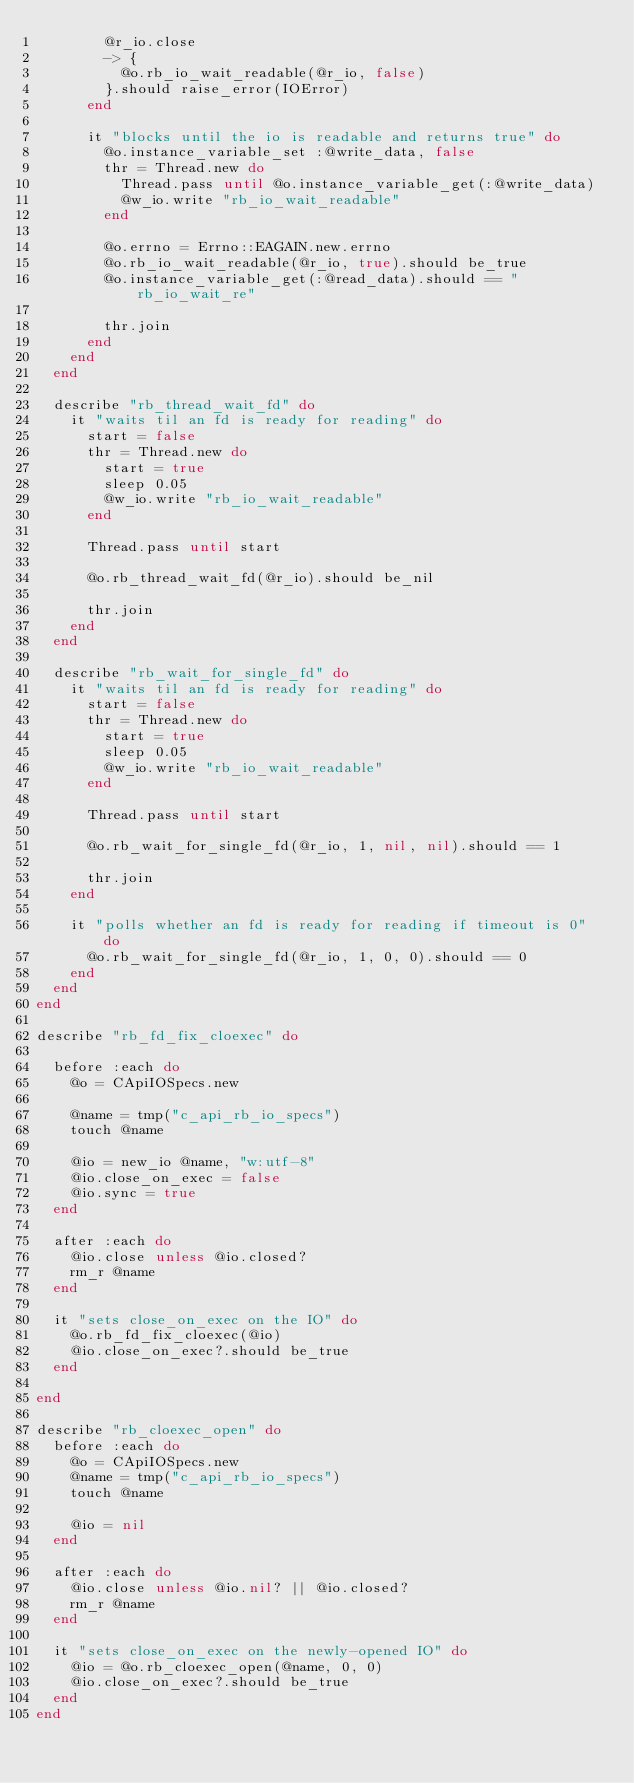Convert code to text. <code><loc_0><loc_0><loc_500><loc_500><_Ruby_>        @r_io.close
        -> {
          @o.rb_io_wait_readable(@r_io, false)
        }.should raise_error(IOError)
      end

      it "blocks until the io is readable and returns true" do
        @o.instance_variable_set :@write_data, false
        thr = Thread.new do
          Thread.pass until @o.instance_variable_get(:@write_data)
          @w_io.write "rb_io_wait_readable"
        end

        @o.errno = Errno::EAGAIN.new.errno
        @o.rb_io_wait_readable(@r_io, true).should be_true
        @o.instance_variable_get(:@read_data).should == "rb_io_wait_re"

        thr.join
      end
    end
  end

  describe "rb_thread_wait_fd" do
    it "waits til an fd is ready for reading" do
      start = false
      thr = Thread.new do
        start = true
        sleep 0.05
        @w_io.write "rb_io_wait_readable"
      end

      Thread.pass until start

      @o.rb_thread_wait_fd(@r_io).should be_nil

      thr.join
    end
  end

  describe "rb_wait_for_single_fd" do
    it "waits til an fd is ready for reading" do
      start = false
      thr = Thread.new do
        start = true
        sleep 0.05
        @w_io.write "rb_io_wait_readable"
      end

      Thread.pass until start

      @o.rb_wait_for_single_fd(@r_io, 1, nil, nil).should == 1

      thr.join
    end

    it "polls whether an fd is ready for reading if timeout is 0" do
      @o.rb_wait_for_single_fd(@r_io, 1, 0, 0).should == 0
    end
  end
end

describe "rb_fd_fix_cloexec" do

  before :each do
    @o = CApiIOSpecs.new

    @name = tmp("c_api_rb_io_specs")
    touch @name

    @io = new_io @name, "w:utf-8"
    @io.close_on_exec = false
    @io.sync = true
  end

  after :each do
    @io.close unless @io.closed?
    rm_r @name
  end

  it "sets close_on_exec on the IO" do
    @o.rb_fd_fix_cloexec(@io)
    @io.close_on_exec?.should be_true
  end

end

describe "rb_cloexec_open" do
  before :each do
    @o = CApiIOSpecs.new
    @name = tmp("c_api_rb_io_specs")
    touch @name

    @io = nil
  end

  after :each do
    @io.close unless @io.nil? || @io.closed?
    rm_r @name
  end

  it "sets close_on_exec on the newly-opened IO" do
    @io = @o.rb_cloexec_open(@name, 0, 0)
    @io.close_on_exec?.should be_true
  end
end
</code> 